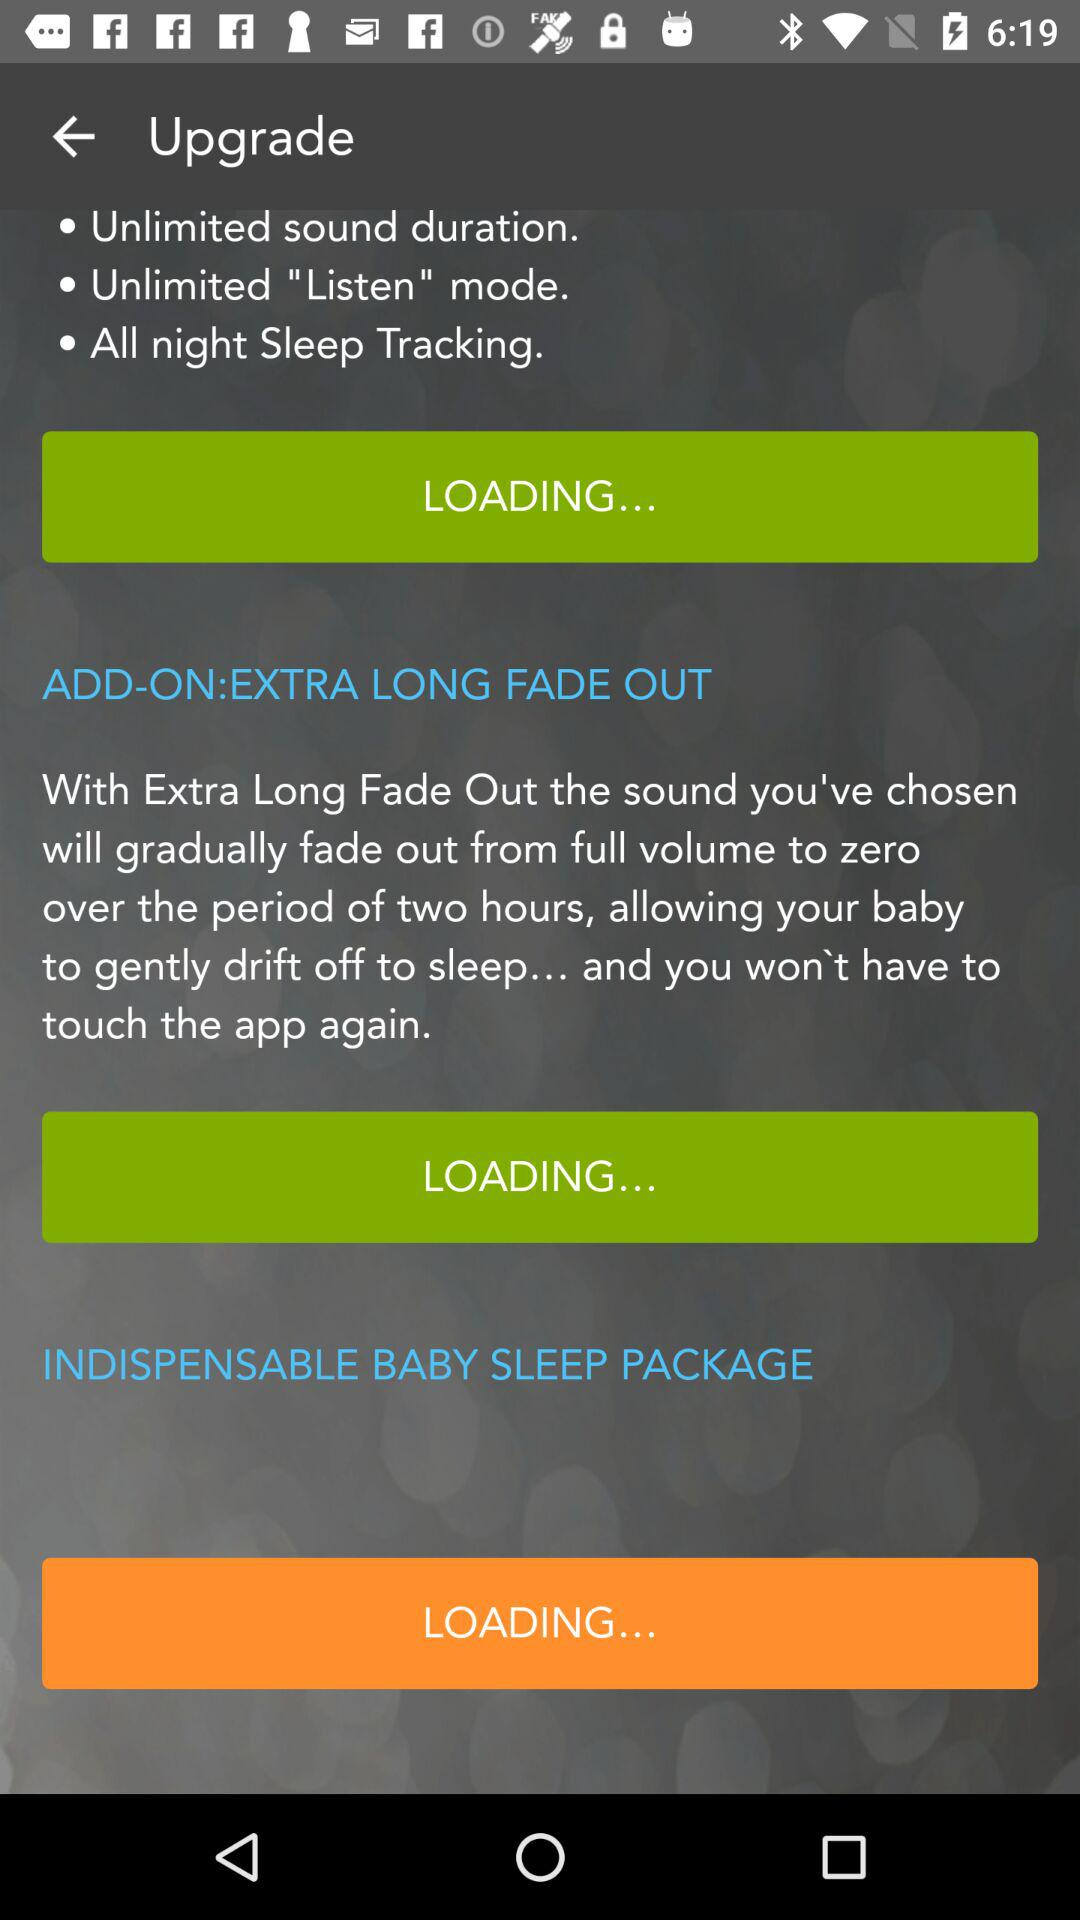How many more features are offered in the Indispensable Baby Sleep Package than the free version?
Answer the question using a single word or phrase. 3 